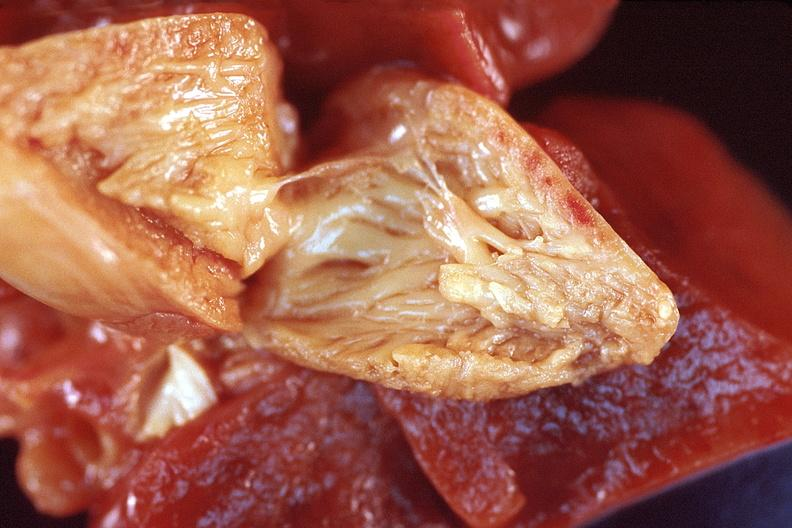does this image show heart, right ventricular enlargement due to a patent ductus arteriosis in a patient with hyaline membrane disease?
Answer the question using a single word or phrase. Yes 